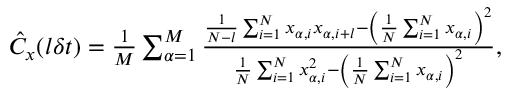Convert formula to latex. <formula><loc_0><loc_0><loc_500><loc_500>\begin{array} { r } { \hat { C } _ { x } ( l \delta t ) = \frac { 1 } { M } \sum _ { \alpha = 1 } ^ { M } \frac { \frac { 1 } { N - l } \sum _ { i = 1 } ^ { N } x _ { \alpha , i } x _ { \alpha , i + l } - \left ( \frac { 1 } { N } \sum _ { i = 1 } ^ { N } x _ { \alpha , i } \right ) ^ { 2 } } { \frac { 1 } { N } \sum _ { i = 1 } ^ { N } x _ { \alpha , i } ^ { 2 } - \left ( \frac { 1 } { N } \sum _ { i = 1 } ^ { N } x _ { \alpha , i } \right ) ^ { 2 } } , } \end{array}</formula> 